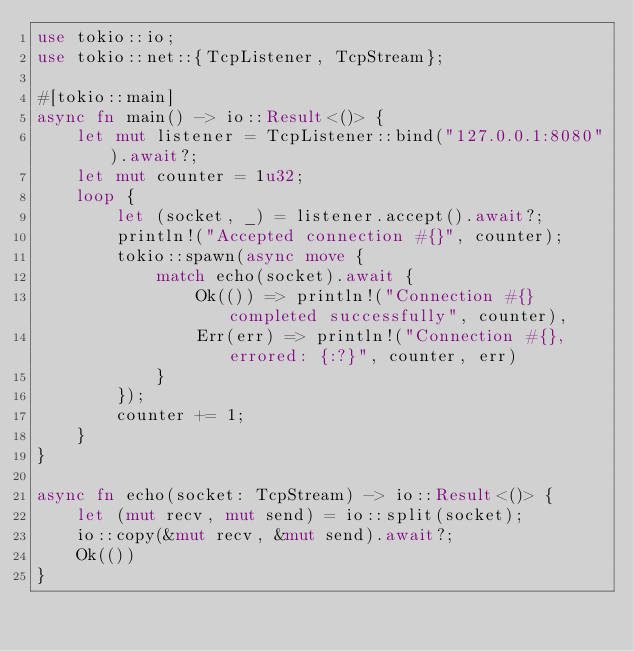<code> <loc_0><loc_0><loc_500><loc_500><_Rust_>use tokio::io;
use tokio::net::{TcpListener, TcpStream};

#[tokio::main]
async fn main() -> io::Result<()> {
    let mut listener = TcpListener::bind("127.0.0.1:8080").await?;
    let mut counter = 1u32;
    loop {
        let (socket, _) = listener.accept().await?;
        println!("Accepted connection #{}", counter);
        tokio::spawn(async move {
            match echo(socket).await {
                Ok(()) => println!("Connection #{} completed successfully", counter),
                Err(err) => println!("Connection #{}, errored: {:?}", counter, err)
            }
        });
        counter += 1;
    }
}

async fn echo(socket: TcpStream) -> io::Result<()> {
    let (mut recv, mut send) = io::split(socket);
    io::copy(&mut recv, &mut send).await?;
    Ok(())
}</code> 